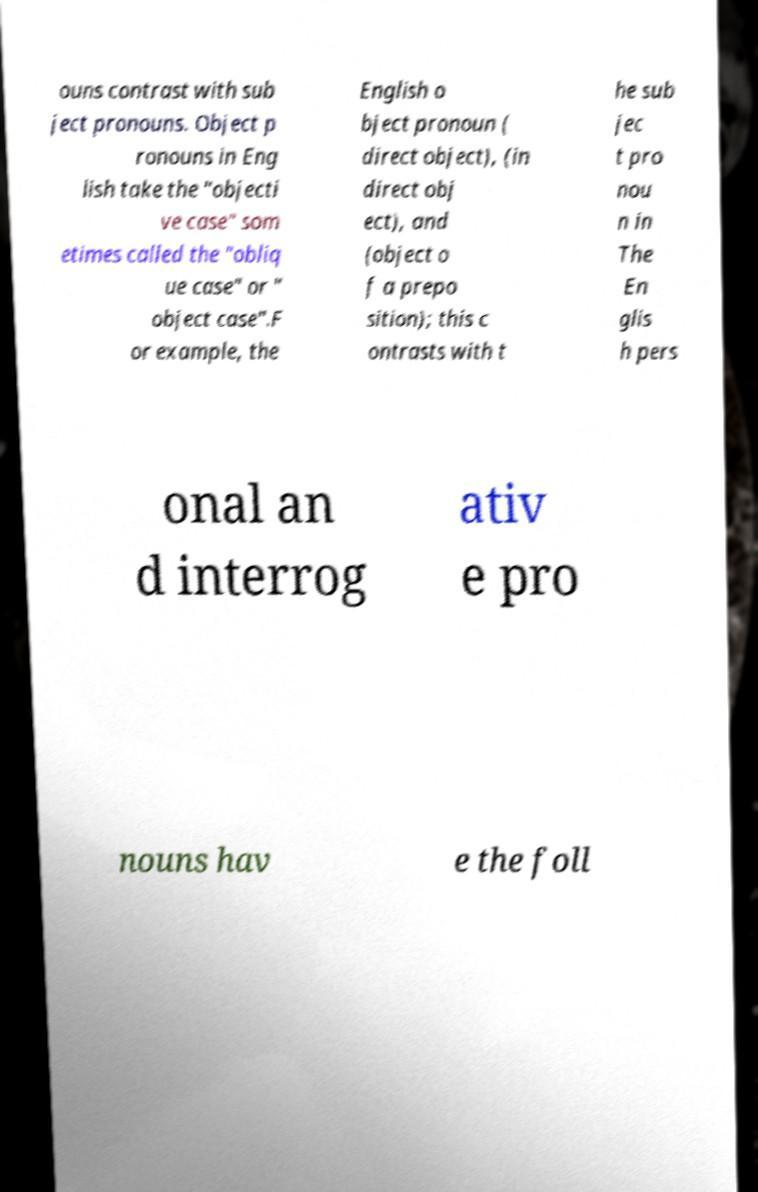What messages or text are displayed in this image? I need them in a readable, typed format. ouns contrast with sub ject pronouns. Object p ronouns in Eng lish take the "objecti ve case" som etimes called the "obliq ue case" or " object case".F or example, the English o bject pronoun ( direct object), (in direct obj ect), and (object o f a prepo sition); this c ontrasts with t he sub jec t pro nou n in The En glis h pers onal an d interrog ativ e pro nouns hav e the foll 